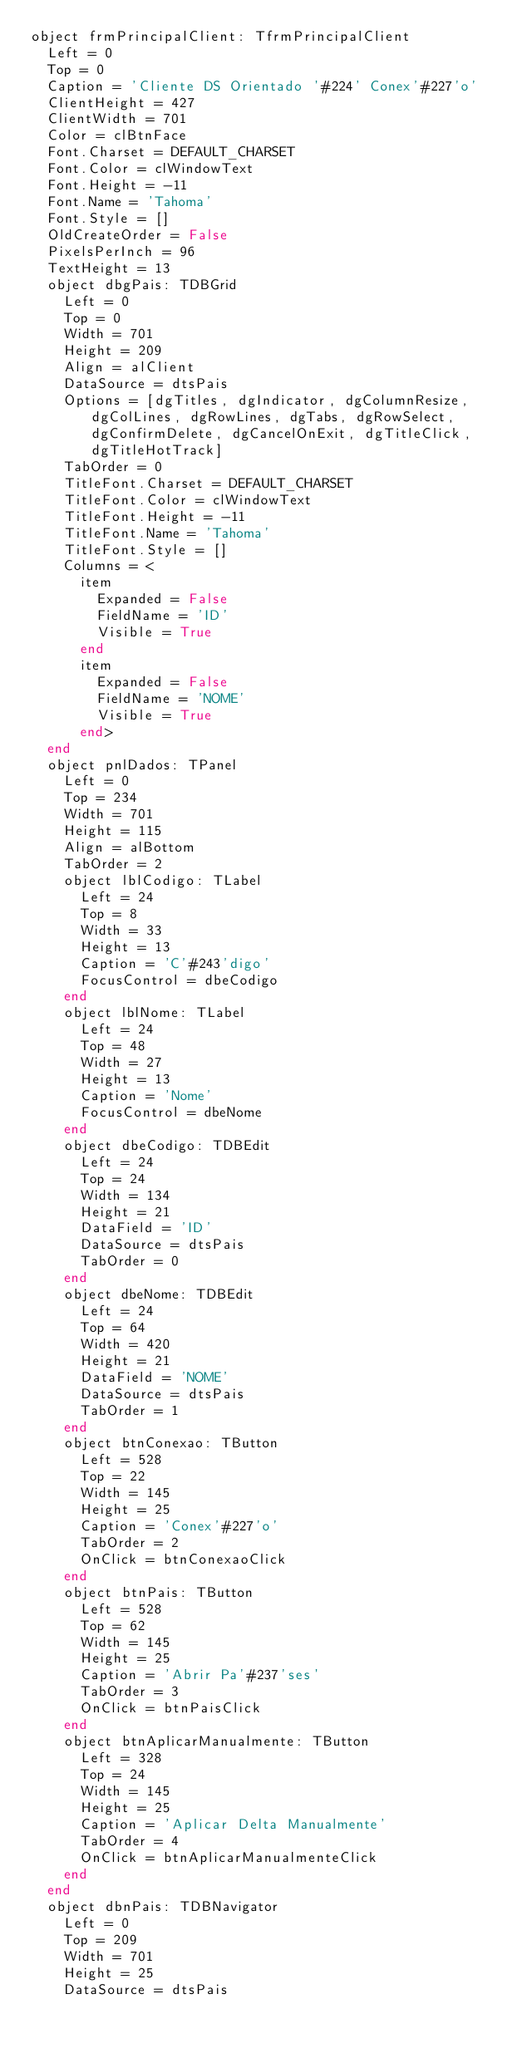Convert code to text. <code><loc_0><loc_0><loc_500><loc_500><_Pascal_>object frmPrincipalClient: TfrmPrincipalClient
  Left = 0
  Top = 0
  Caption = 'Cliente DS Orientado '#224' Conex'#227'o'
  ClientHeight = 427
  ClientWidth = 701
  Color = clBtnFace
  Font.Charset = DEFAULT_CHARSET
  Font.Color = clWindowText
  Font.Height = -11
  Font.Name = 'Tahoma'
  Font.Style = []
  OldCreateOrder = False
  PixelsPerInch = 96
  TextHeight = 13
  object dbgPais: TDBGrid
    Left = 0
    Top = 0
    Width = 701
    Height = 209
    Align = alClient
    DataSource = dtsPais
    Options = [dgTitles, dgIndicator, dgColumnResize, dgColLines, dgRowLines, dgTabs, dgRowSelect, dgConfirmDelete, dgCancelOnExit, dgTitleClick, dgTitleHotTrack]
    TabOrder = 0
    TitleFont.Charset = DEFAULT_CHARSET
    TitleFont.Color = clWindowText
    TitleFont.Height = -11
    TitleFont.Name = 'Tahoma'
    TitleFont.Style = []
    Columns = <
      item
        Expanded = False
        FieldName = 'ID'
        Visible = True
      end
      item
        Expanded = False
        FieldName = 'NOME'
        Visible = True
      end>
  end
  object pnlDados: TPanel
    Left = 0
    Top = 234
    Width = 701
    Height = 115
    Align = alBottom
    TabOrder = 2
    object lblCodigo: TLabel
      Left = 24
      Top = 8
      Width = 33
      Height = 13
      Caption = 'C'#243'digo'
      FocusControl = dbeCodigo
    end
    object lblNome: TLabel
      Left = 24
      Top = 48
      Width = 27
      Height = 13
      Caption = 'Nome'
      FocusControl = dbeNome
    end
    object dbeCodigo: TDBEdit
      Left = 24
      Top = 24
      Width = 134
      Height = 21
      DataField = 'ID'
      DataSource = dtsPais
      TabOrder = 0
    end
    object dbeNome: TDBEdit
      Left = 24
      Top = 64
      Width = 420
      Height = 21
      DataField = 'NOME'
      DataSource = dtsPais
      TabOrder = 1
    end
    object btnConexao: TButton
      Left = 528
      Top = 22
      Width = 145
      Height = 25
      Caption = 'Conex'#227'o'
      TabOrder = 2
      OnClick = btnConexaoClick
    end
    object btnPais: TButton
      Left = 528
      Top = 62
      Width = 145
      Height = 25
      Caption = 'Abrir Pa'#237'ses'
      TabOrder = 3
      OnClick = btnPaisClick
    end
    object btnAplicarManualmente: TButton
      Left = 328
      Top = 24
      Width = 145
      Height = 25
      Caption = 'Aplicar Delta Manualmente'
      TabOrder = 4
      OnClick = btnAplicarManualmenteClick
    end
  end
  object dbnPais: TDBNavigator
    Left = 0
    Top = 209
    Width = 701
    Height = 25
    DataSource = dtsPais</code> 